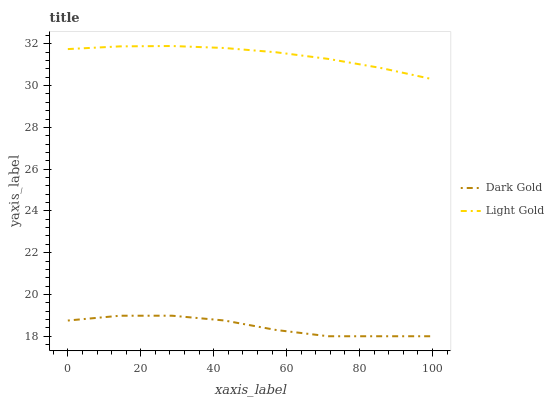Does Dark Gold have the minimum area under the curve?
Answer yes or no. Yes. Does Light Gold have the maximum area under the curve?
Answer yes or no. Yes. Does Dark Gold have the maximum area under the curve?
Answer yes or no. No. Is Light Gold the smoothest?
Answer yes or no. Yes. Is Dark Gold the roughest?
Answer yes or no. Yes. Is Dark Gold the smoothest?
Answer yes or no. No. Does Dark Gold have the lowest value?
Answer yes or no. Yes. Does Light Gold have the highest value?
Answer yes or no. Yes. Does Dark Gold have the highest value?
Answer yes or no. No. Is Dark Gold less than Light Gold?
Answer yes or no. Yes. Is Light Gold greater than Dark Gold?
Answer yes or no. Yes. Does Dark Gold intersect Light Gold?
Answer yes or no. No. 